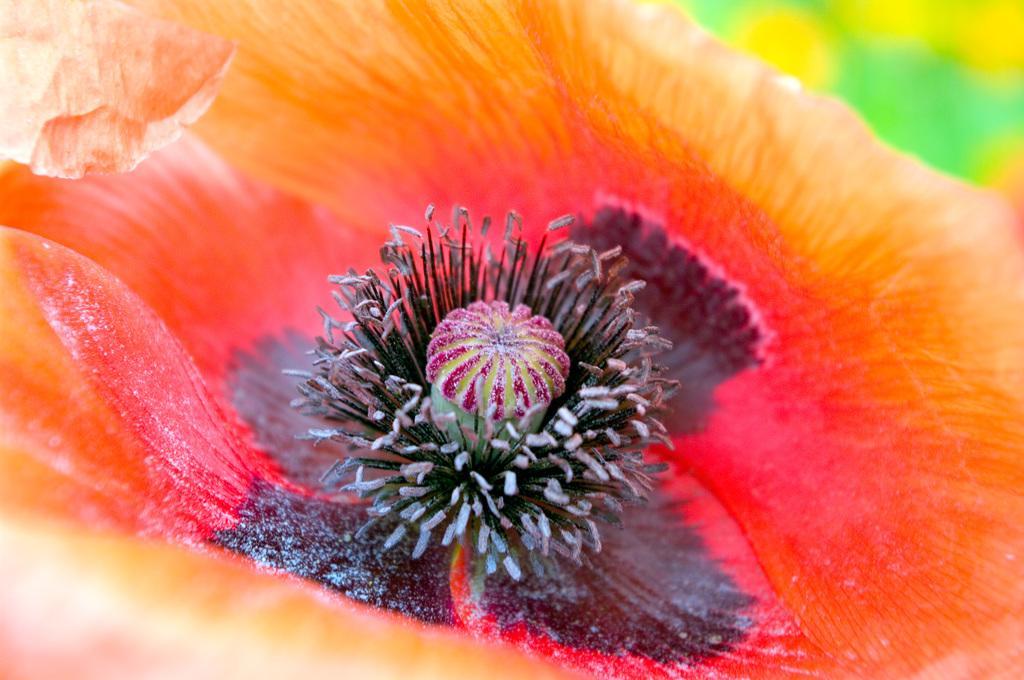Describe this image in one or two sentences. In this image I can see a flower and its buds in the front. I can see color of the flower is orange, red and black. 